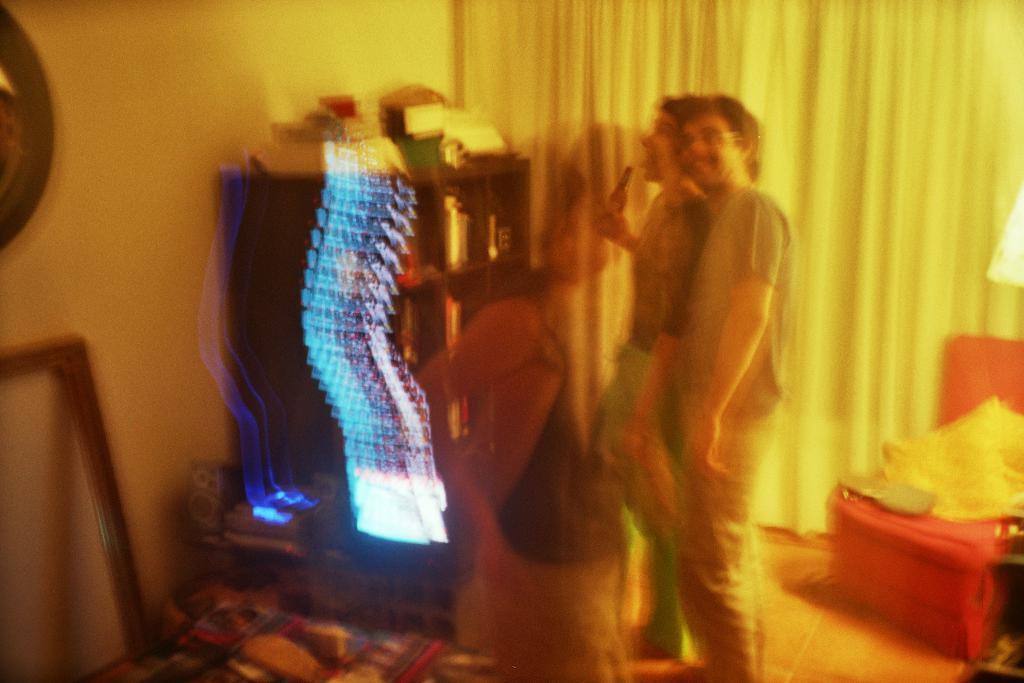Can you describe this image briefly? In this on the right side, I can see the light. I can also see some object on the chair. I can see two people. I can see some objects in the shelf. I can also see the image is blurred. 